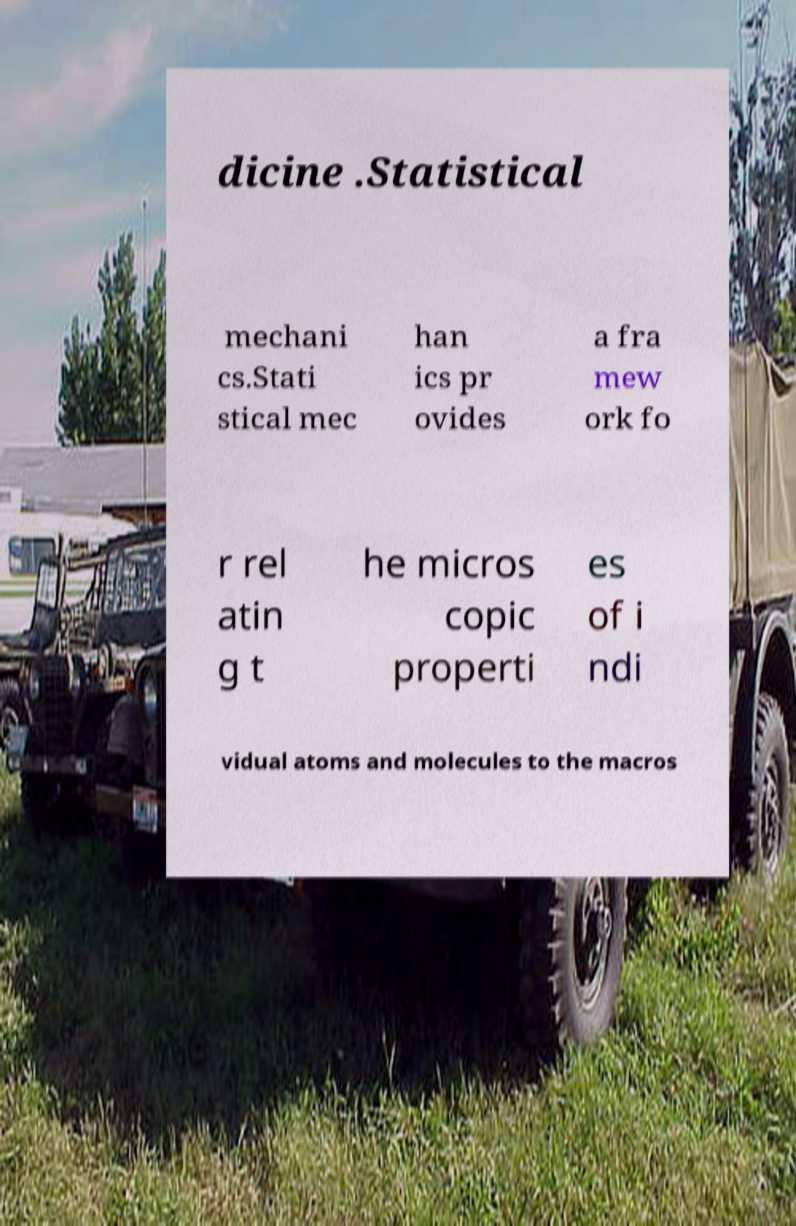What messages or text are displayed in this image? I need them in a readable, typed format. dicine .Statistical mechani cs.Stati stical mec han ics pr ovides a fra mew ork fo r rel atin g t he micros copic properti es of i ndi vidual atoms and molecules to the macros 